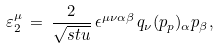Convert formula to latex. <formula><loc_0><loc_0><loc_500><loc_500>\varepsilon _ { 2 } ^ { \mu } \, = \, \frac { 2 } { \sqrt { s t u } } \, \epsilon ^ { \mu \nu \alpha \beta } \, q _ { \nu } ( p _ { p } ) _ { \alpha } p _ { \beta } ,</formula> 